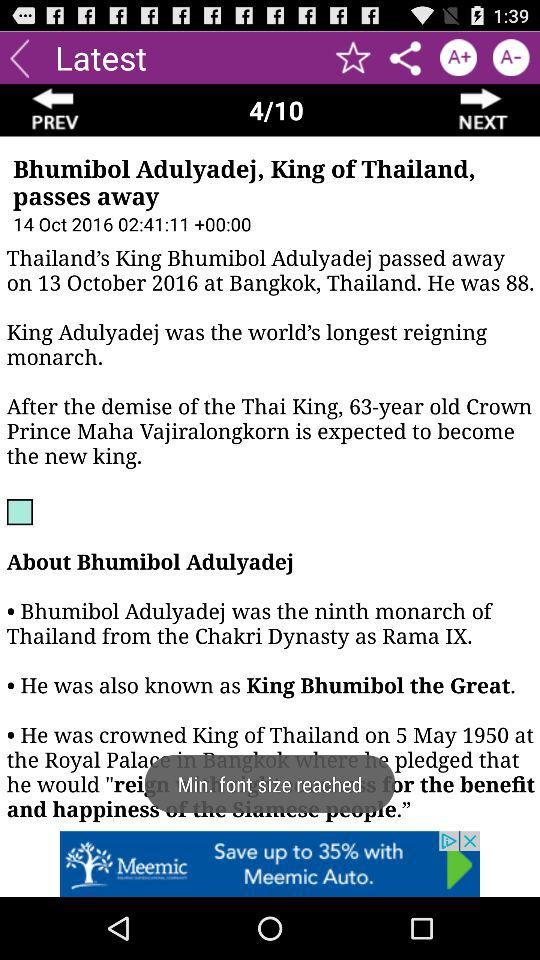How many more years was King Bhumibol Adulyadej older than Crown Prince Maha Vajiralongkorn?
Answer the question using a single word or phrase. 25 